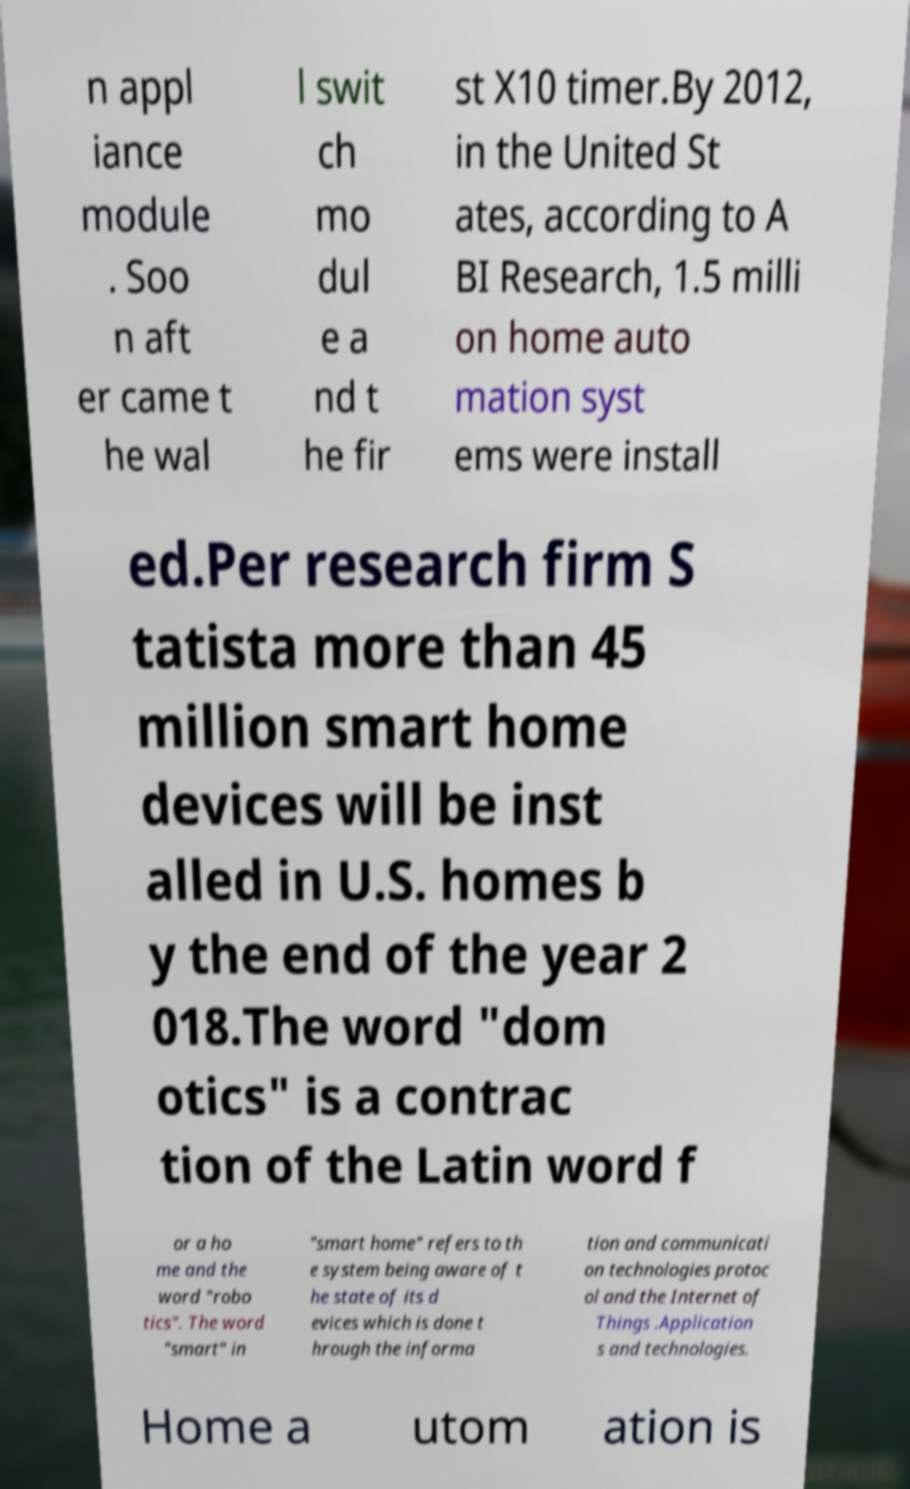Could you extract and type out the text from this image? n appl iance module . Soo n aft er came t he wal l swit ch mo dul e a nd t he fir st X10 timer.By 2012, in the United St ates, according to A BI Research, 1.5 milli on home auto mation syst ems were install ed.Per research firm S tatista more than 45 million smart home devices will be inst alled in U.S. homes b y the end of the year 2 018.The word "dom otics" is a contrac tion of the Latin word f or a ho me and the word "robo tics". The word "smart" in "smart home" refers to th e system being aware of t he state of its d evices which is done t hrough the informa tion and communicati on technologies protoc ol and the Internet of Things .Application s and technologies. Home a utom ation is 